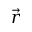<formula> <loc_0><loc_0><loc_500><loc_500>\vec { r }</formula> 